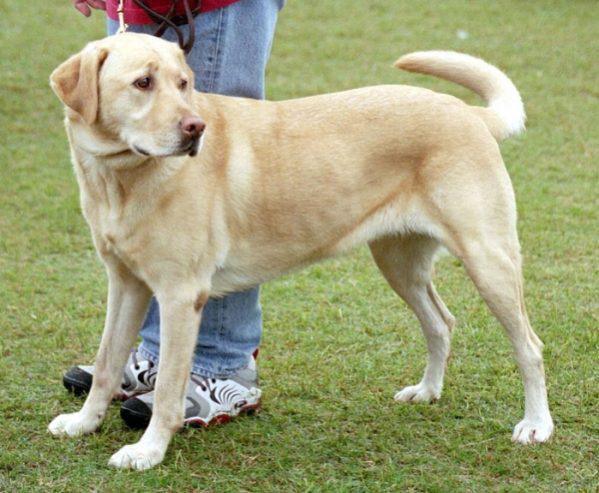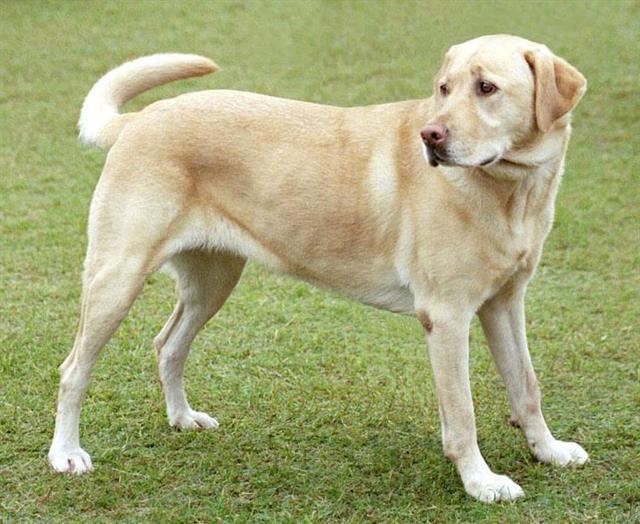The first image is the image on the left, the second image is the image on the right. For the images shown, is this caption "One of the animals is not on the grass." true? Answer yes or no. No. 